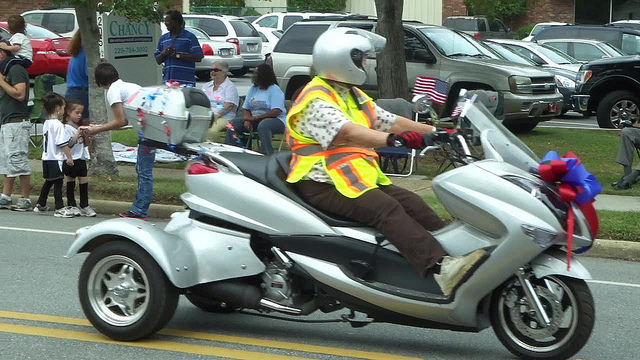Extract all visible text content from this image. CHACY 